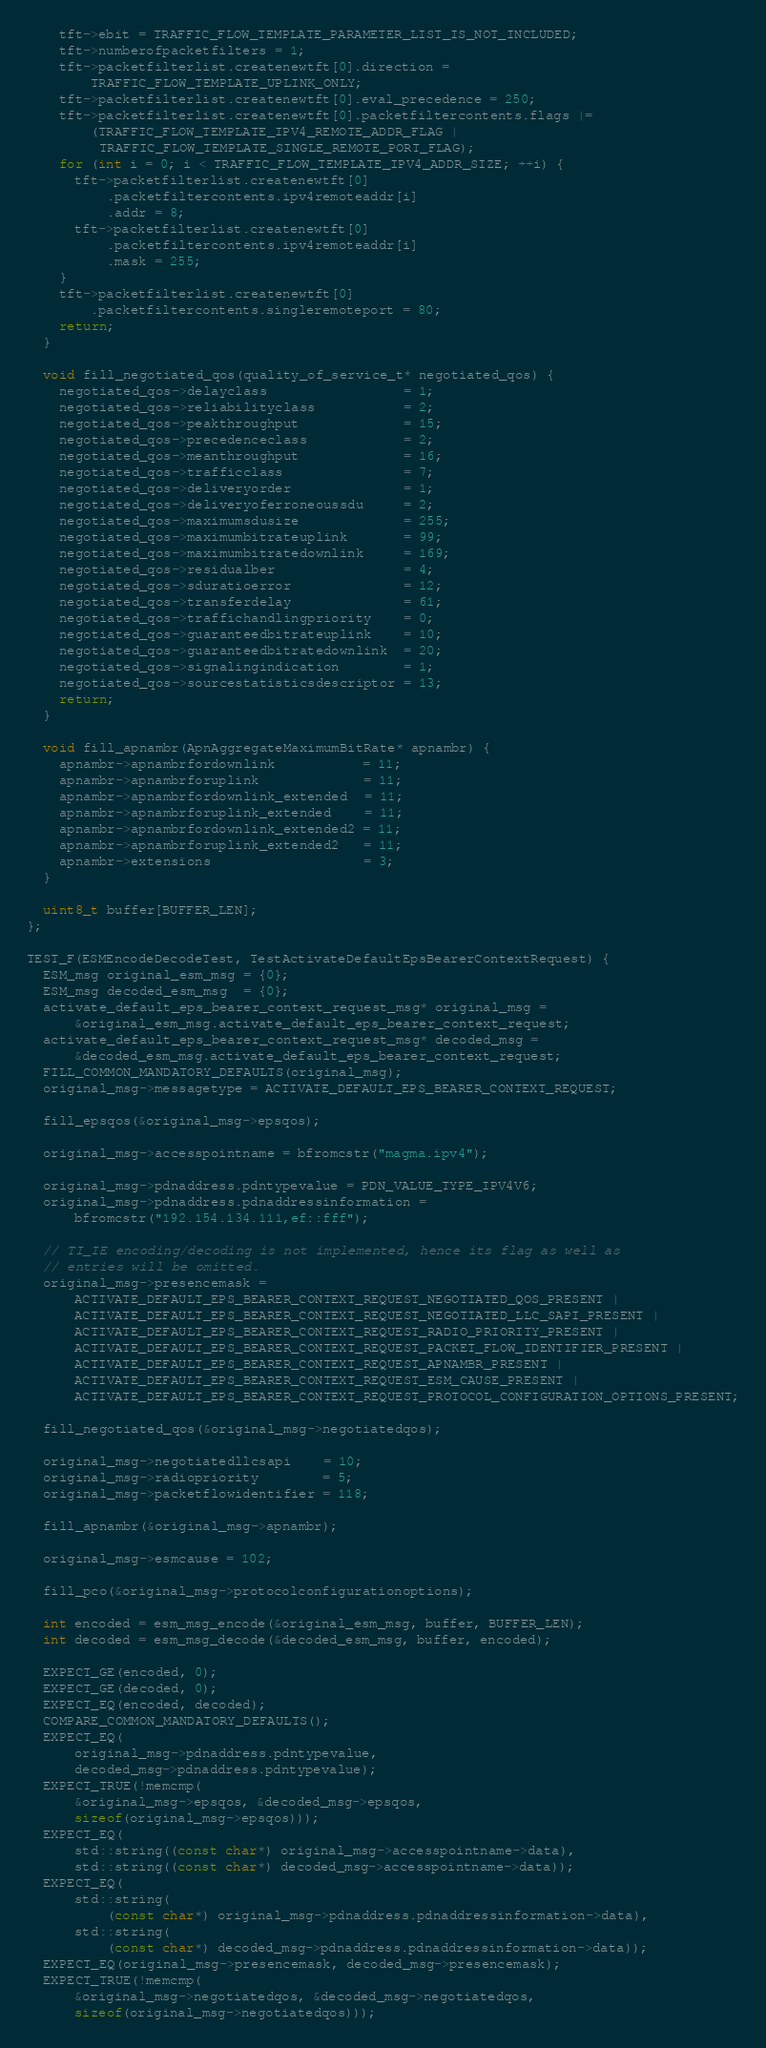Convert code to text. <code><loc_0><loc_0><loc_500><loc_500><_C++_>    tft->ebit = TRAFFIC_FLOW_TEMPLATE_PARAMETER_LIST_IS_NOT_INCLUDED;
    tft->numberofpacketfilters = 1;
    tft->packetfilterlist.createnewtft[0].direction =
        TRAFFIC_FLOW_TEMPLATE_UPLINK_ONLY;
    tft->packetfilterlist.createnewtft[0].eval_precedence = 250;
    tft->packetfilterlist.createnewtft[0].packetfiltercontents.flags |=
        (TRAFFIC_FLOW_TEMPLATE_IPV4_REMOTE_ADDR_FLAG |
         TRAFFIC_FLOW_TEMPLATE_SINGLE_REMOTE_PORT_FLAG);
    for (int i = 0; i < TRAFFIC_FLOW_TEMPLATE_IPV4_ADDR_SIZE; ++i) {
      tft->packetfilterlist.createnewtft[0]
          .packetfiltercontents.ipv4remoteaddr[i]
          .addr = 8;
      tft->packetfilterlist.createnewtft[0]
          .packetfiltercontents.ipv4remoteaddr[i]
          .mask = 255;
    }
    tft->packetfilterlist.createnewtft[0]
        .packetfiltercontents.singleremoteport = 80;
    return;
  }

  void fill_negotiated_qos(quality_of_service_t* negotiated_qos) {
    negotiated_qos->delayclass                 = 1;
    negotiated_qos->reliabilityclass           = 2;
    negotiated_qos->peakthroughput             = 15;
    negotiated_qos->precedenceclass            = 2;
    negotiated_qos->meanthroughput             = 16;
    negotiated_qos->trafficclass               = 7;
    negotiated_qos->deliveryorder              = 1;
    negotiated_qos->deliveryoferroneoussdu     = 2;
    negotiated_qos->maximumsdusize             = 255;
    negotiated_qos->maximumbitrateuplink       = 99;
    negotiated_qos->maximumbitratedownlink     = 169;
    negotiated_qos->residualber                = 4;
    negotiated_qos->sduratioerror              = 12;
    negotiated_qos->transferdelay              = 61;
    negotiated_qos->traffichandlingpriority    = 0;
    negotiated_qos->guaranteedbitrateuplink    = 10;
    negotiated_qos->guaranteedbitratedownlink  = 20;
    negotiated_qos->signalingindication        = 1;
    negotiated_qos->sourcestatisticsdescriptor = 13;
    return;
  }

  void fill_apnambr(ApnAggregateMaximumBitRate* apnambr) {
    apnambr->apnambrfordownlink           = 11;
    apnambr->apnambrforuplink             = 11;
    apnambr->apnambrfordownlink_extended  = 11;
    apnambr->apnambrforuplink_extended    = 11;
    apnambr->apnambrfordownlink_extended2 = 11;
    apnambr->apnambrforuplink_extended2   = 11;
    apnambr->extensions                   = 3;
  }

  uint8_t buffer[BUFFER_LEN];
};

TEST_F(ESMEncodeDecodeTest, TestActivateDefaultEpsBearerContextRequest) {
  ESM_msg original_esm_msg = {0};
  ESM_msg decoded_esm_msg  = {0};
  activate_default_eps_bearer_context_request_msg* original_msg =
      &original_esm_msg.activate_default_eps_bearer_context_request;
  activate_default_eps_bearer_context_request_msg* decoded_msg =
      &decoded_esm_msg.activate_default_eps_bearer_context_request;
  FILL_COMMON_MANDATORY_DEFAULTS(original_msg);
  original_msg->messagetype = ACTIVATE_DEFAULT_EPS_BEARER_CONTEXT_REQUEST;

  fill_epsqos(&original_msg->epsqos);

  original_msg->accesspointname = bfromcstr("magma.ipv4");

  original_msg->pdnaddress.pdntypevalue = PDN_VALUE_TYPE_IPV4V6;
  original_msg->pdnaddress.pdnaddressinformation =
      bfromcstr("192.154.134.111,ef::fff");

  // TI_IE encoding/decoding is not implemented, hence its flag as well as
  // entries will be omitted.
  original_msg->presencemask =
      ACTIVATE_DEFAULT_EPS_BEARER_CONTEXT_REQUEST_NEGOTIATED_QOS_PRESENT |
      ACTIVATE_DEFAULT_EPS_BEARER_CONTEXT_REQUEST_NEGOTIATED_LLC_SAPI_PRESENT |
      ACTIVATE_DEFAULT_EPS_BEARER_CONTEXT_REQUEST_RADIO_PRIORITY_PRESENT |
      ACTIVATE_DEFAULT_EPS_BEARER_CONTEXT_REQUEST_PACKET_FLOW_IDENTIFIER_PRESENT |
      ACTIVATE_DEFAULT_EPS_BEARER_CONTEXT_REQUEST_APNAMBR_PRESENT |
      ACTIVATE_DEFAULT_EPS_BEARER_CONTEXT_REQUEST_ESM_CAUSE_PRESENT |
      ACTIVATE_DEFAULT_EPS_BEARER_CONTEXT_REQUEST_PROTOCOL_CONFIGURATION_OPTIONS_PRESENT;

  fill_negotiated_qos(&original_msg->negotiatedqos);

  original_msg->negotiatedllcsapi    = 10;
  original_msg->radiopriority        = 5;
  original_msg->packetflowidentifier = 118;

  fill_apnambr(&original_msg->apnambr);

  original_msg->esmcause = 102;

  fill_pco(&original_msg->protocolconfigurationoptions);

  int encoded = esm_msg_encode(&original_esm_msg, buffer, BUFFER_LEN);
  int decoded = esm_msg_decode(&decoded_esm_msg, buffer, encoded);

  EXPECT_GE(encoded, 0);
  EXPECT_GE(decoded, 0);
  EXPECT_EQ(encoded, decoded);
  COMPARE_COMMON_MANDATORY_DEFAULTS();
  EXPECT_EQ(
      original_msg->pdnaddress.pdntypevalue,
      decoded_msg->pdnaddress.pdntypevalue);
  EXPECT_TRUE(!memcmp(
      &original_msg->epsqos, &decoded_msg->epsqos,
      sizeof(original_msg->epsqos)));
  EXPECT_EQ(
      std::string((const char*) original_msg->accesspointname->data),
      std::string((const char*) decoded_msg->accesspointname->data));
  EXPECT_EQ(
      std::string(
          (const char*) original_msg->pdnaddress.pdnaddressinformation->data),
      std::string(
          (const char*) decoded_msg->pdnaddress.pdnaddressinformation->data));
  EXPECT_EQ(original_msg->presencemask, decoded_msg->presencemask);
  EXPECT_TRUE(!memcmp(
      &original_msg->negotiatedqos, &decoded_msg->negotiatedqos,
      sizeof(original_msg->negotiatedqos)));</code> 